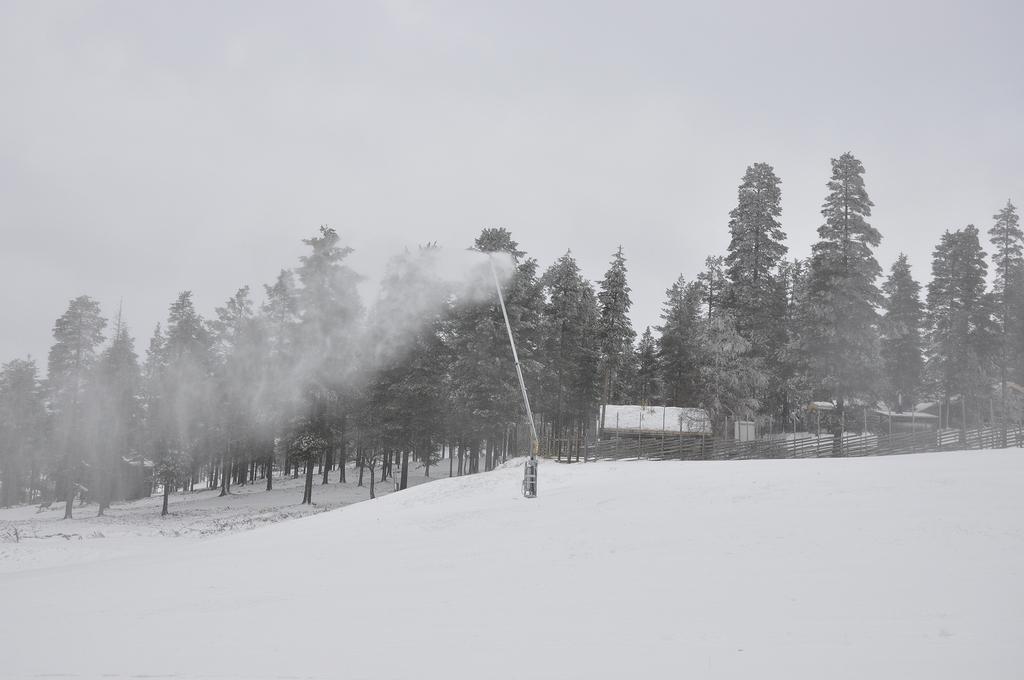Please provide a concise description of this image. At the bottom we can see snow and there is an object on the snow. In the background there are trees,houses,fence and sky. 